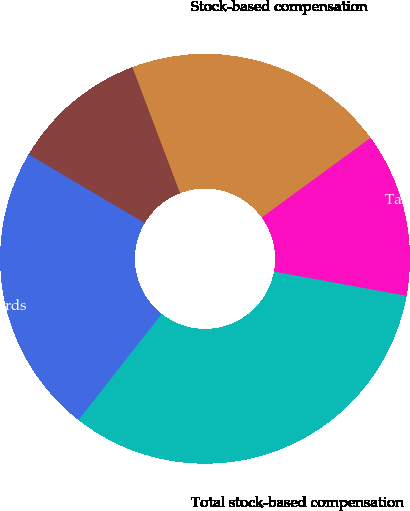<chart> <loc_0><loc_0><loc_500><loc_500><pie_chart><fcel>Stock options<fcel>Restricted stock awards<fcel>Total stock-based compensation<fcel>Tax benefit recognized<fcel>Stock-based compensation<nl><fcel>10.75%<fcel>22.91%<fcel>32.69%<fcel>12.94%<fcel>20.71%<nl></chart> 